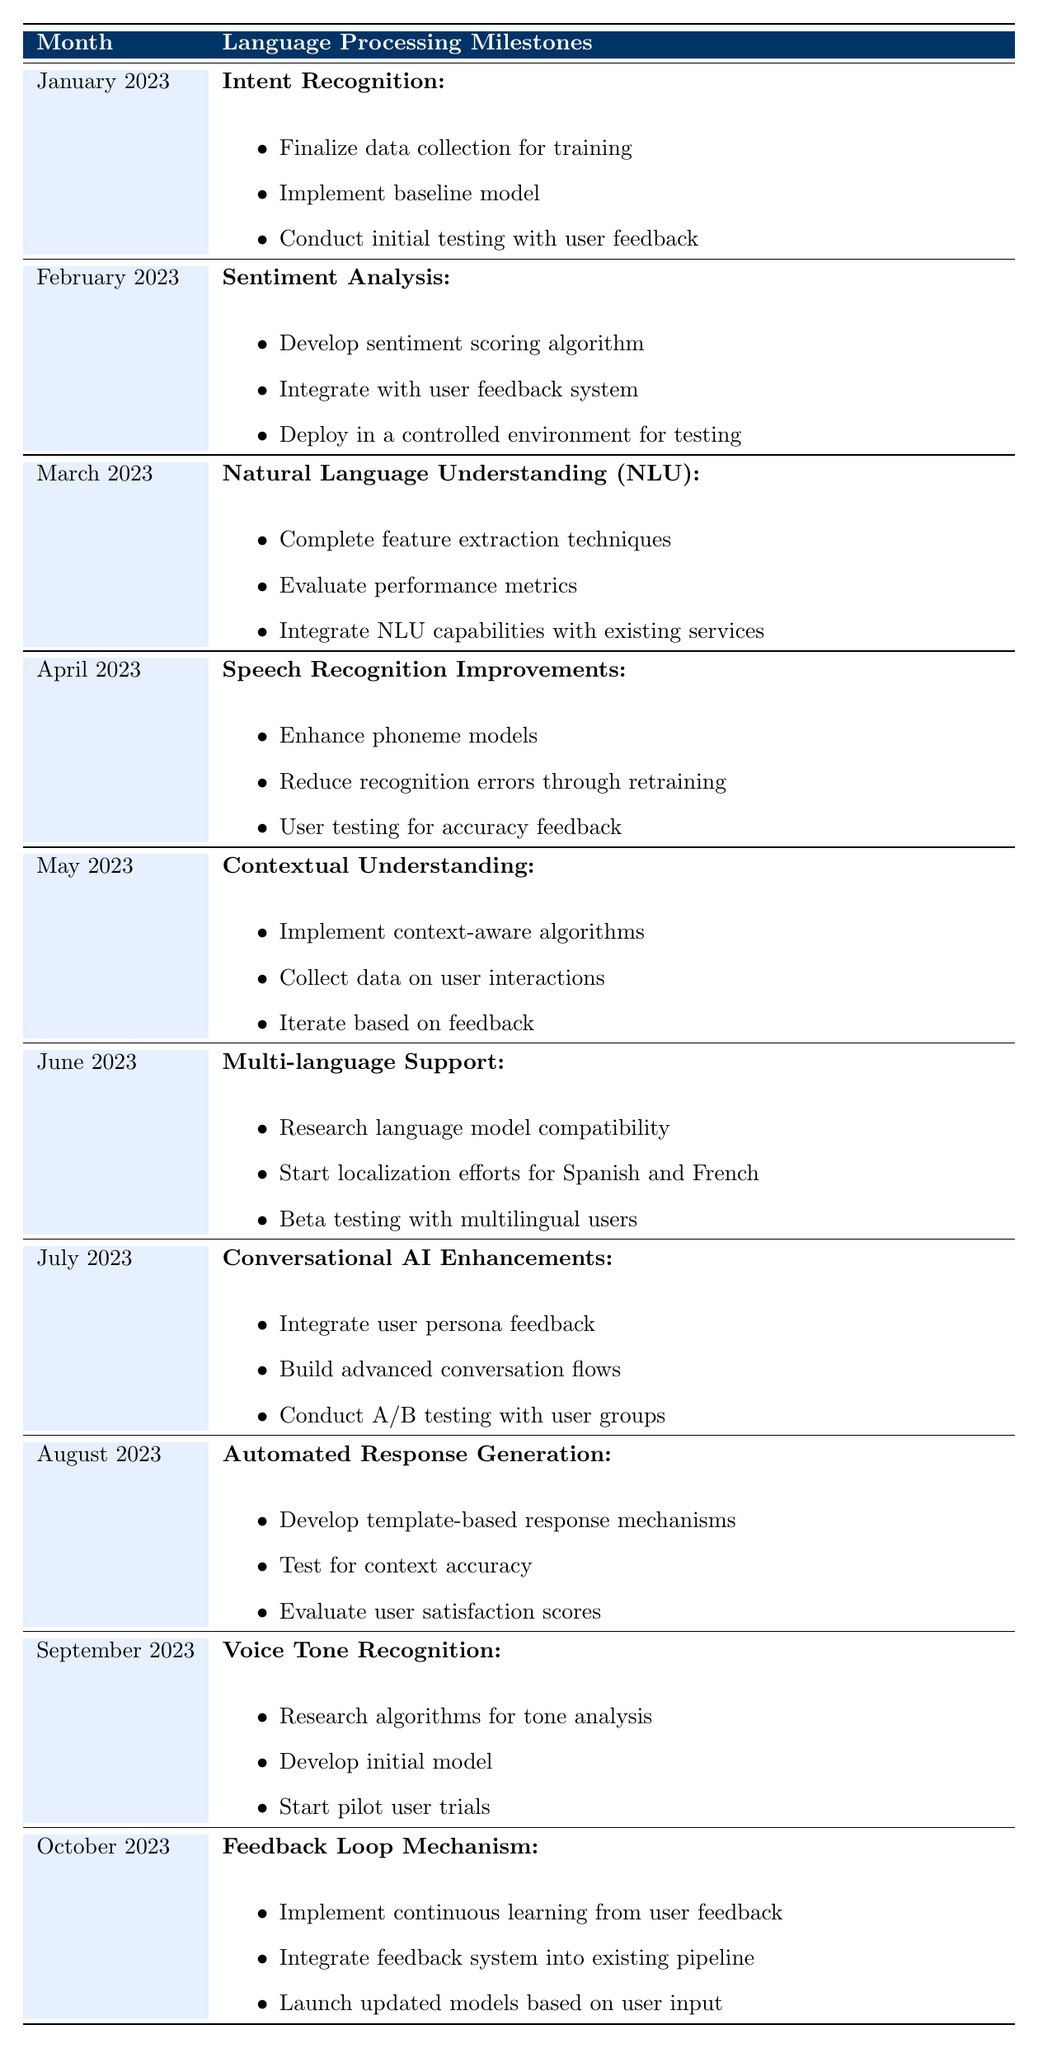What language processing feature was focused on in June 2023? The table has a row for June 2023, and lists the feature discussed as "Multi-language Support." This can be retrieved directly from the relevant cell for that month.
Answer: Multi-language Support Which month included milestones for Speech Recognition Improvements? The entry for April 2023 details the milestones under the feature "Speech Recognition Improvements." By locating this month, the required information can be confirmed.
Answer: April 2023 Did the month of May 2023 have any deliverables for Voice Tone Recognition? The table indicates that Voice Tone Recognition is a feature listed under September 2023, meaning May 2023 does not include any deliverables for it, confirming this statement is false.
Answer: No How many deliverables were listed for the Contextual Understanding feature in May 2023? The table for May 2023 specifies three deliverables related to Contextual Understanding. By counting the items in the corresponding list, the answer can be derived.
Answer: Three Which feature had its initial testing conducted in January 2023, and what were the deliverables associated with it? Referring to January 2023 in the table identifies the feature as "Intent Recognition." The deliverables include finalizing data collection, implementing a baseline model, and conducting initial testing with user feedback.
Answer: Intent Recognition; Finalize data collection for training, Implement baseline model, Conduct initial testing with user feedback What is the difference in the number of deliverables between the features for July 2023 and August 2023? July 2023 has three deliverables under "Conversational AI Enhancements," while August 2023 lists three for "Automated Response Generation." Thus, the difference in deliverables is zero, as both have the same count.
Answer: Zero How many features were focused on throughout the ten-month period from January 2023 to October 2023? By inspecting each month's section in the table, it's evident that there are ten distinct features listed across each month, indicating multiple facets of development.
Answer: Ten Was there any feature relating to sentiment analysis in the milestones before September 2023? The table shows that sentiment analysis is explicitly mentioned for February 2023, which is before September, confirming this query is true.
Answer: Yes What were the final actions taken for the Feedback Loop Mechanism in October 2023? The table entry for October 2023 reveals three distinct deliverables for the Feedback Loop Mechanism, including implementing continuous learning from feedback, integrating the feedback system, and launching updated models.
Answer: Implement continuous learning, Integrate feedback system, Launch updated models 